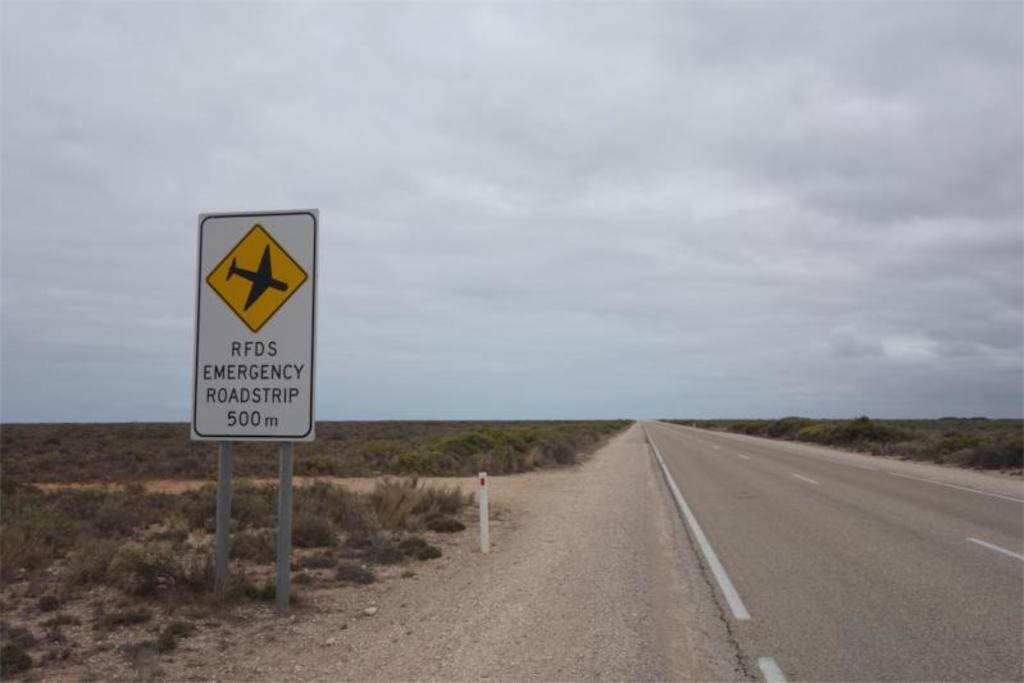How far ahead is the emergency roadstrip?
Keep it short and to the point. 500m. 